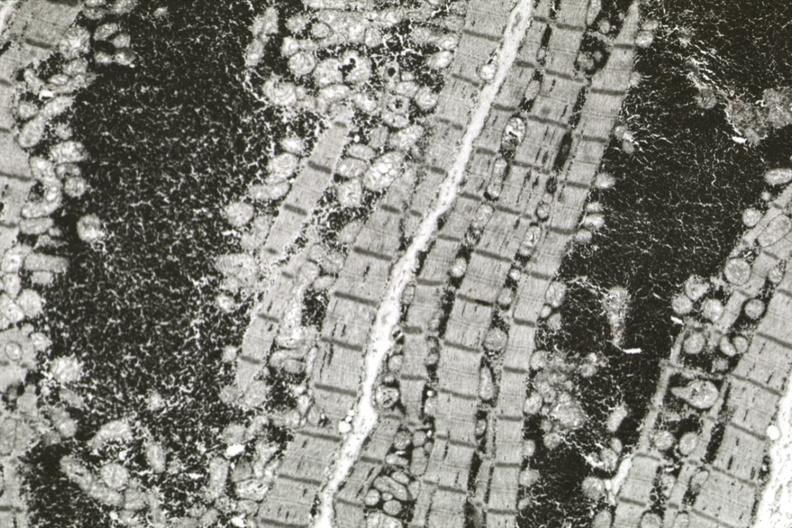does this image show excessive number mitochondria especially about nucleus early atrophy?
Answer the question using a single word or phrase. Yes 